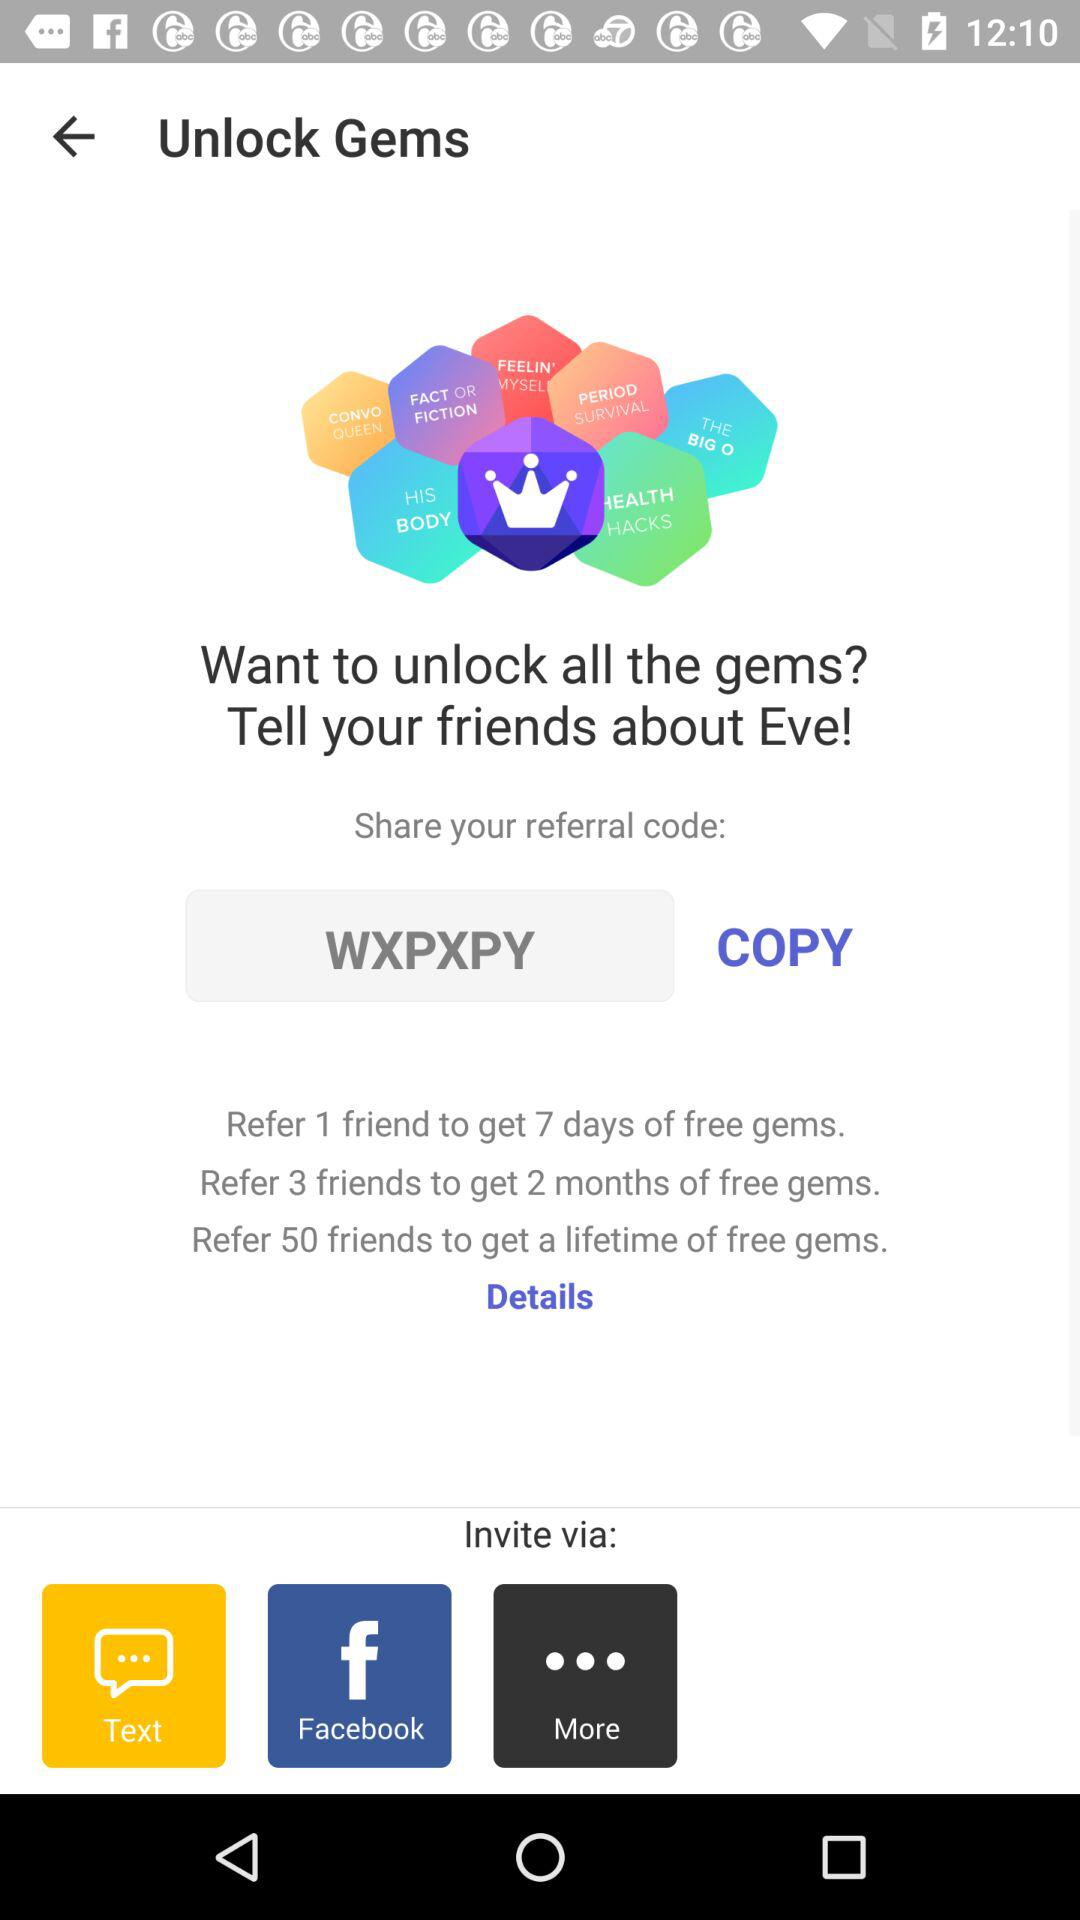How many friends can we refer to get a free gem for life?
Answer the question using a single word or phrase. You can refer 50 friends to get a free gem for life 